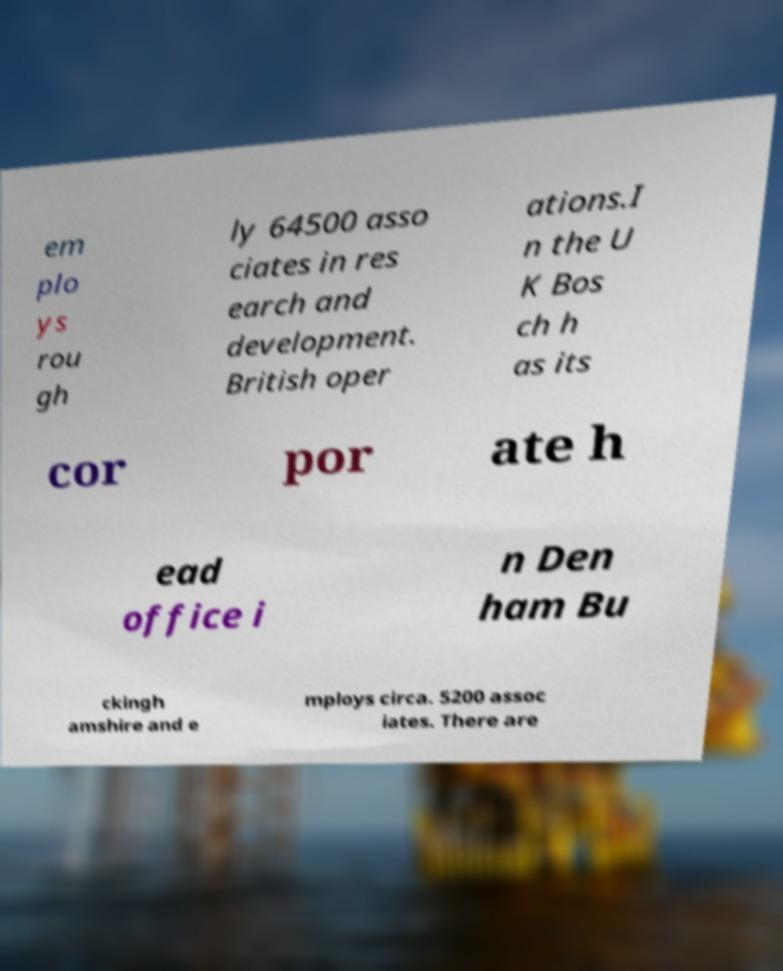I need the written content from this picture converted into text. Can you do that? em plo ys rou gh ly 64500 asso ciates in res earch and development. British oper ations.I n the U K Bos ch h as its cor por ate h ead office i n Den ham Bu ckingh amshire and e mploys circa. 5200 assoc iates. There are 